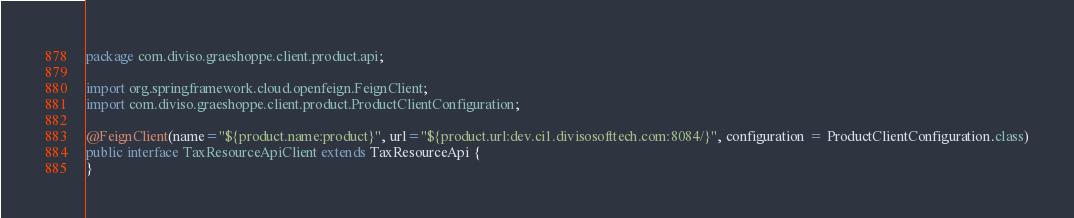Convert code to text. <code><loc_0><loc_0><loc_500><loc_500><_Java_>package com.diviso.graeshoppe.client.product.api;

import org.springframework.cloud.openfeign.FeignClient;
import com.diviso.graeshoppe.client.product.ProductClientConfiguration;

@FeignClient(name="${product.name:product}", url="${product.url:dev.ci1.divisosofttech.com:8084/}", configuration = ProductClientConfiguration.class)
public interface TaxResourceApiClient extends TaxResourceApi {
}</code> 